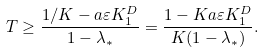<formula> <loc_0><loc_0><loc_500><loc_500>T \geq \frac { 1 / K - a \varepsilon K _ { 1 } ^ { D } } { 1 - \lambda _ { * } } = \frac { 1 - K a \varepsilon K _ { 1 } ^ { D } } { K ( 1 - \lambda _ { * } ) } .</formula> 